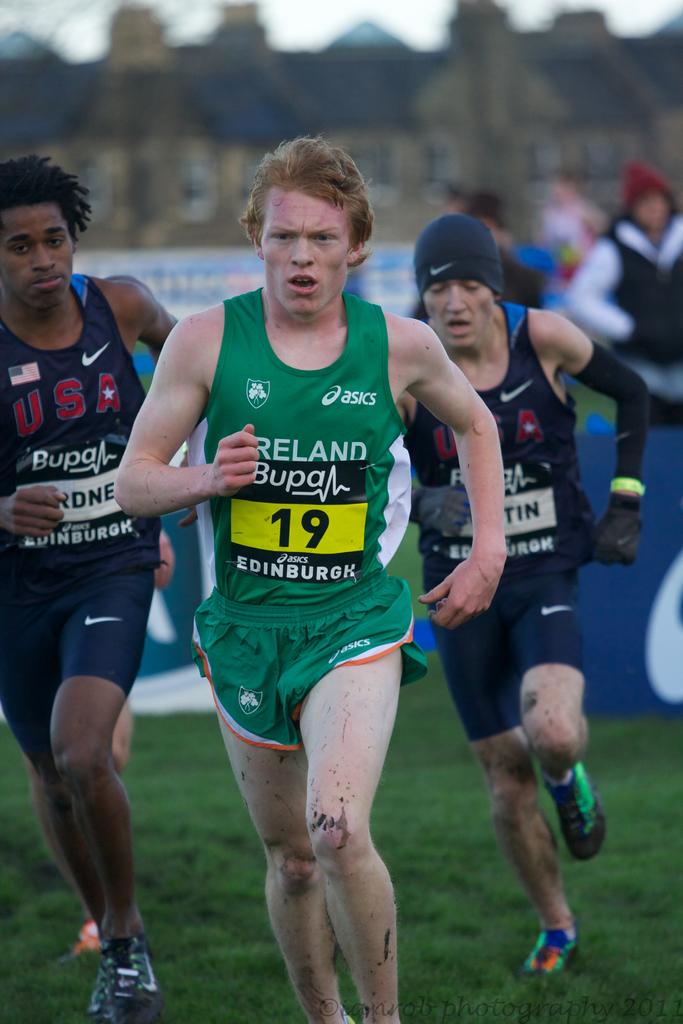What brand shirt is green wearing?
Offer a terse response. Asics. What country is this player in green representing?
Keep it short and to the point. Ireland. 